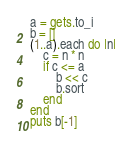Convert code to text. <code><loc_0><loc_0><loc_500><loc_500><_Ruby_>a = gets.to_i
b = []
(1..a).each do |n|
	c = n * n
	if c <= a
		b << c
		b.sort
	end
end
puts b[-1]</code> 